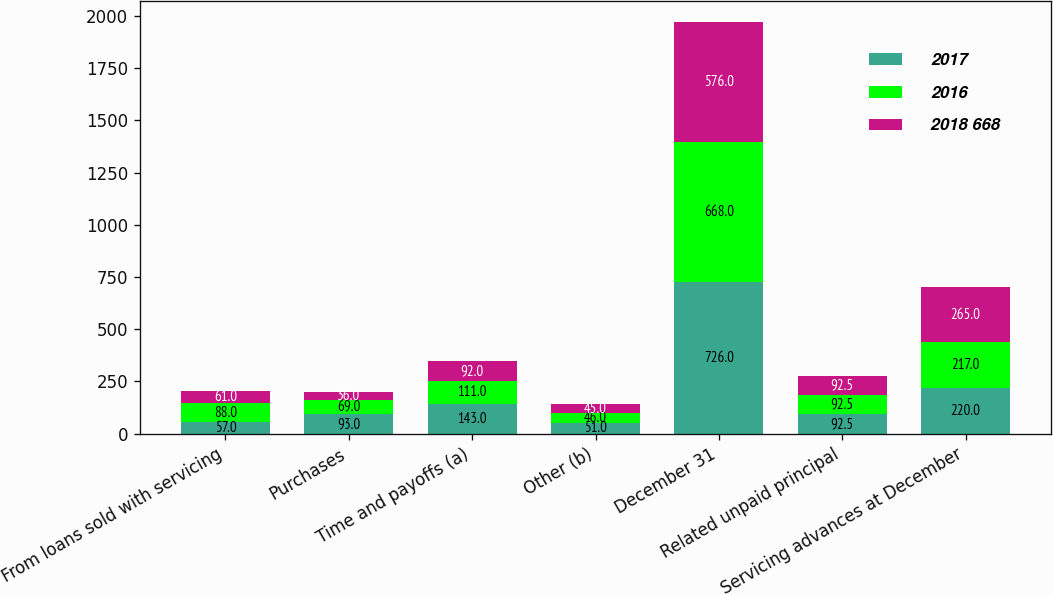Convert chart. <chart><loc_0><loc_0><loc_500><loc_500><stacked_bar_chart><ecel><fcel>From loans sold with servicing<fcel>Purchases<fcel>Time and payoffs (a)<fcel>Other (b)<fcel>December 31<fcel>Related unpaid principal<fcel>Servicing advances at December<nl><fcel>2017<fcel>57<fcel>93<fcel>143<fcel>51<fcel>726<fcel>92.5<fcel>220<nl><fcel>2016<fcel>88<fcel>69<fcel>111<fcel>46<fcel>668<fcel>92.5<fcel>217<nl><fcel>2018 668<fcel>61<fcel>36<fcel>92<fcel>45<fcel>576<fcel>92.5<fcel>265<nl></chart> 